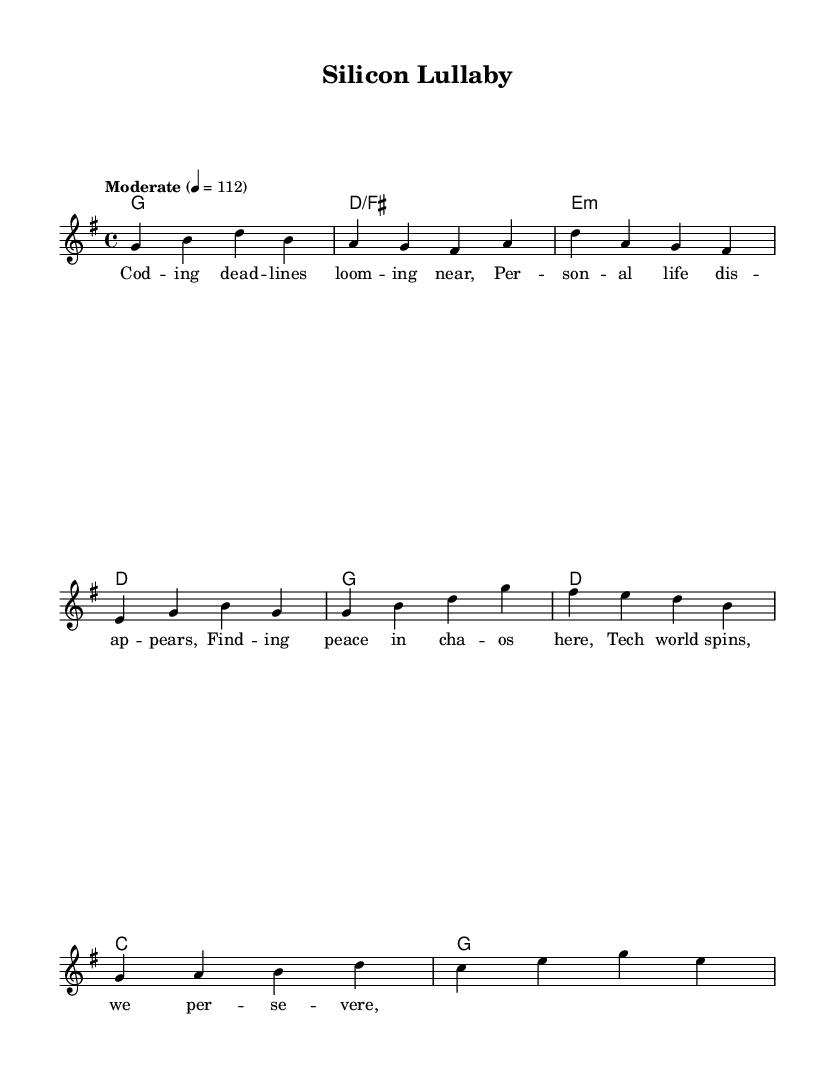What is the key signature of this music? The key signature indicated for the piece is G major, which includes one sharp (F#). This can be determined by looking at the key signature symbol placed at the beginning of the staff.
Answer: G major What is the time signature of this music? The time signature is 4/4, as shown at the beginning of the score. It means there are four beats in each measure, and the quarter note gets one beat.
Answer: 4/4 What is the tempo marking for this piece? The tempo marking is "Moderate" with a metronome marking of 112 beats per minute. This is indicated in the tempo line at the beginning, which typically gives guidance on the speed of the performance.
Answer: Moderate 4 = 112 What are the first two words of the verses? The first two words of the verses are found in the verse lyrics section, which begins with "Cod" followed by "ing." This can be confirmed by reading the lyric text aligned with the melody notes in the score.
Answer: Cod ing How many measures are there in the chorus? The chorus consists of four measures, which can be counted by looking at the notation where the chorus lyrics and melody are notated together. Each measure is defined by vertical bar lines separating the groups of notes.
Answer: 4 What is the first chord used in the verse? The first chord in the verse is G major, represented as "g1" in the chord section. This information can be found by checking the harmony notation that aligns with the verse melody.
Answer: G Which phrase of the lyrics suggests a sense of struggle? The phrase "Per son al life dis ap pears" conveys a sense of struggle, as it reflects the loss of personal life due to the pressures of work in the tech industry. Analyzing the lyrics alongside their thematic context reveals emotional undertones.
Answer: Per son al life dis ap pears 